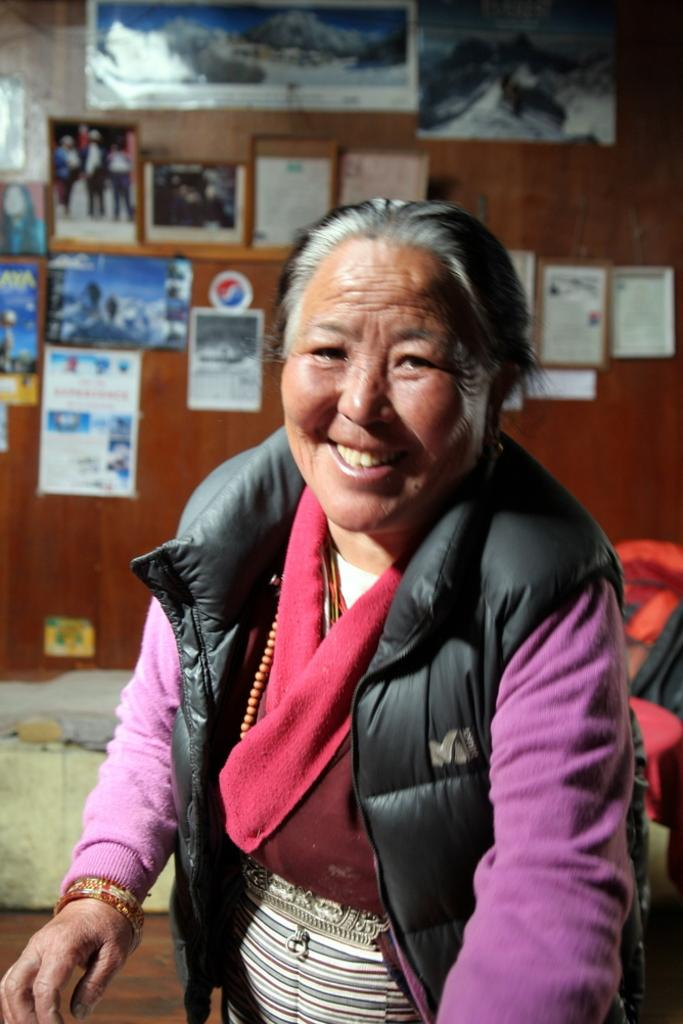What is the main subject of the image? There is an old woman standing in the image. Can you describe the old woman's appearance or clothing? Unfortunately, the provided facts do not give any information about the old woman's appearance or clothing. What other objects or subjects can be seen in the background of the image? The provided facts only mention that there are other objects in the background of the image, but they do not specify what those objects are. How much butter is being used by the old woman in the image? There is no butter present in the image, so it is not possible to determine how much butter the old woman might be using. 